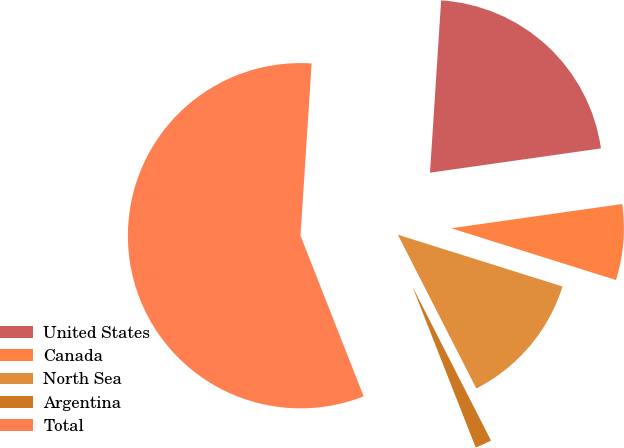Convert chart to OTSL. <chart><loc_0><loc_0><loc_500><loc_500><pie_chart><fcel>United States<fcel>Canada<fcel>North Sea<fcel>Argentina<fcel>Total<nl><fcel>21.73%<fcel>7.09%<fcel>12.64%<fcel>1.55%<fcel>56.99%<nl></chart> 